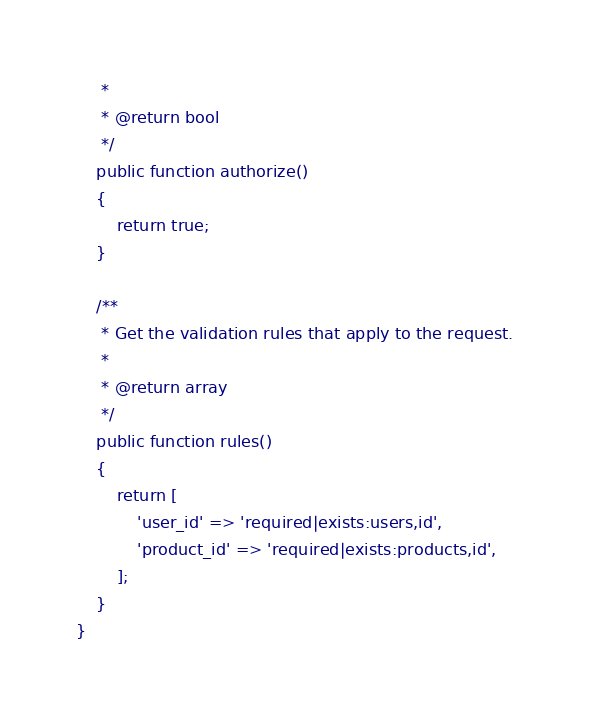Convert code to text. <code><loc_0><loc_0><loc_500><loc_500><_PHP_>     *
     * @return bool
     */
    public function authorize()
    {
        return true;
    }

    /**
     * Get the validation rules that apply to the request.
     *
     * @return array
     */
    public function rules()
    {
        return [
            'user_id' => 'required|exists:users,id',
            'product_id' => 'required|exists:products,id',
        ];
    }
}
</code> 